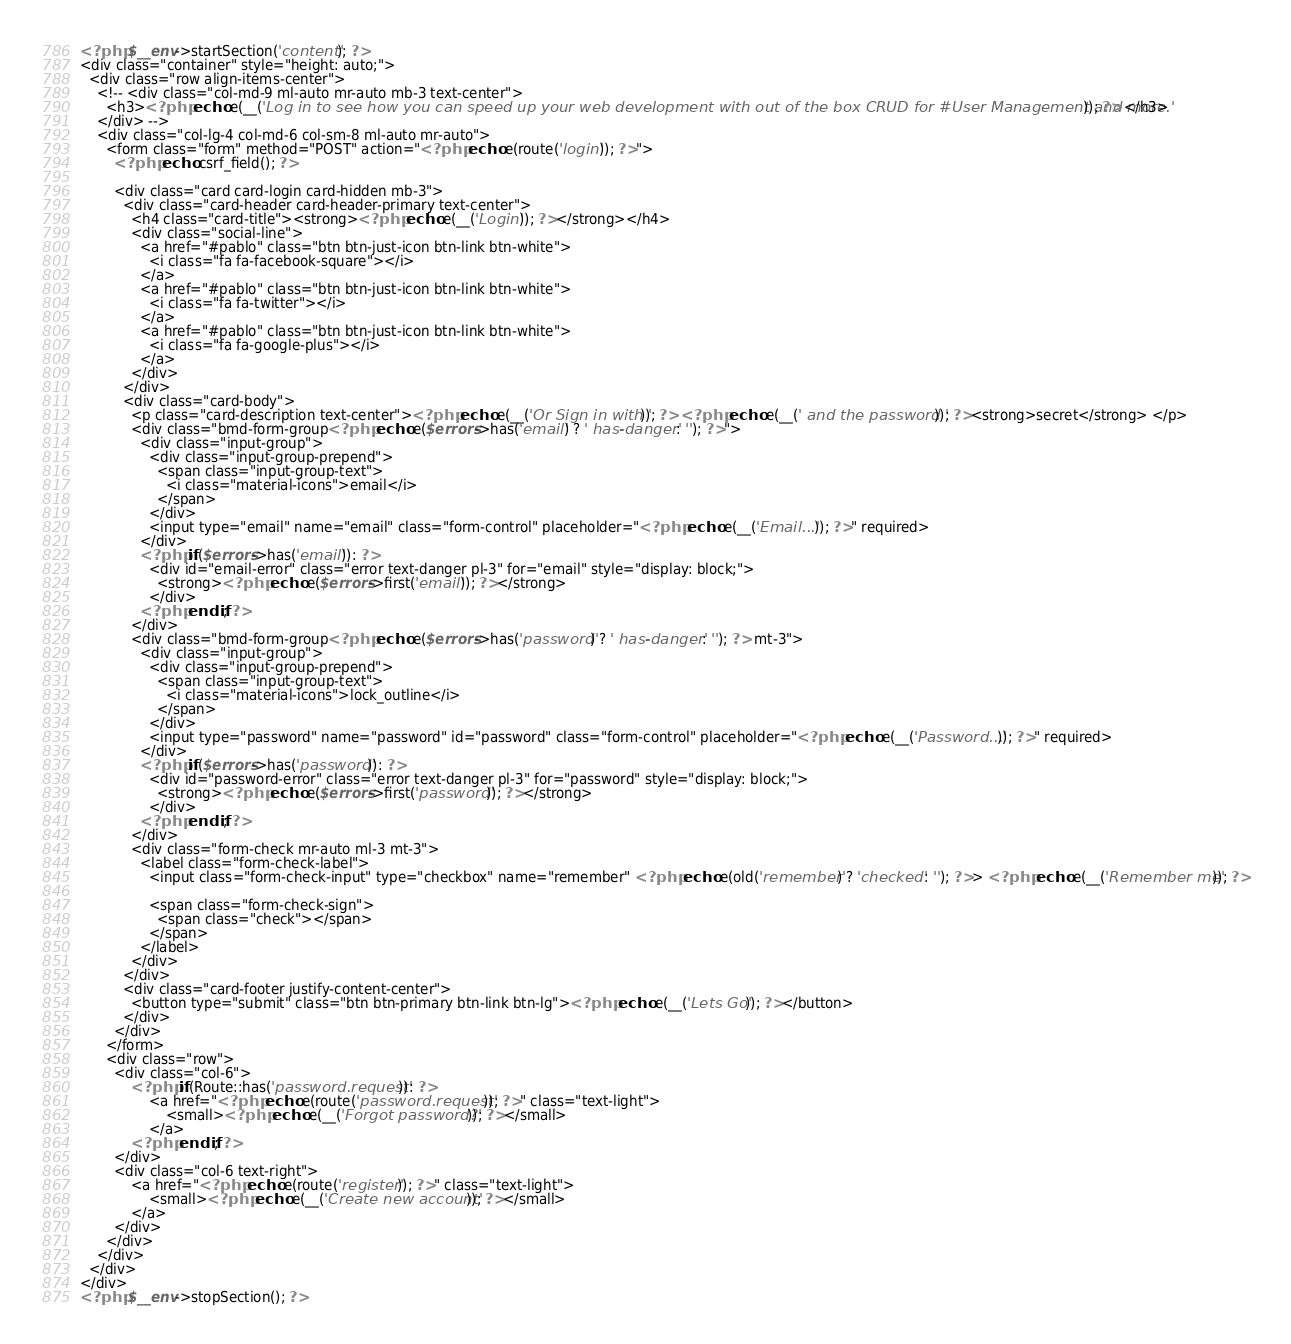Convert code to text. <code><loc_0><loc_0><loc_500><loc_500><_PHP_>

<?php $__env->startSection('content'); ?>
<div class="container" style="height: auto;">
  <div class="row align-items-center">
    <!-- <div class="col-md-9 ml-auto mr-auto mb-3 text-center">
      <h3><?php echo e(__('Log in to see how you can speed up your web development with out of the box CRUD for #User Management and more.')); ?> </h3>
    </div> -->
    <div class="col-lg-4 col-md-6 col-sm-8 ml-auto mr-auto">
      <form class="form" method="POST" action="<?php echo e(route('login')); ?>">
        <?php echo csrf_field(); ?>

        <div class="card card-login card-hidden mb-3">
          <div class="card-header card-header-primary text-center">
            <h4 class="card-title"><strong><?php echo e(__('Login')); ?></strong></h4>
            <div class="social-line">
              <a href="#pablo" class="btn btn-just-icon btn-link btn-white">
                <i class="fa fa-facebook-square"></i>
              </a>
              <a href="#pablo" class="btn btn-just-icon btn-link btn-white">
                <i class="fa fa-twitter"></i>
              </a>
              <a href="#pablo" class="btn btn-just-icon btn-link btn-white">
                <i class="fa fa-google-plus"></i>
              </a>
            </div>
          </div>
          <div class="card-body">
            <p class="card-description text-center"><?php echo e(__('Or Sign in with ')); ?> <?php echo e(__(' and the password ')); ?><strong>secret</strong> </p>
            <div class="bmd-form-group<?php echo e($errors->has('email') ? ' has-danger' : ''); ?>">
              <div class="input-group">
                <div class="input-group-prepend">
                  <span class="input-group-text">
                    <i class="material-icons">email</i>
                  </span>
                </div>
                <input type="email" name="email" class="form-control" placeholder="<?php echo e(__('Email...')); ?>" required>
              </div>
              <?php if($errors->has('email')): ?>
                <div id="email-error" class="error text-danger pl-3" for="email" style="display: block;">
                  <strong><?php echo e($errors->first('email')); ?></strong>
                </div>
              <?php endif; ?>
            </div>
            <div class="bmd-form-group<?php echo e($errors->has('password') ? ' has-danger' : ''); ?> mt-3">
              <div class="input-group">
                <div class="input-group-prepend">
                  <span class="input-group-text">
                    <i class="material-icons">lock_outline</i>
                  </span>
                </div>
                <input type="password" name="password" id="password" class="form-control" placeholder="<?php echo e(__('Password...')); ?>" required>
              </div>
              <?php if($errors->has('password')): ?>
                <div id="password-error" class="error text-danger pl-3" for="password" style="display: block;">
                  <strong><?php echo e($errors->first('password')); ?></strong>
                </div>
              <?php endif; ?>
            </div>
            <div class="form-check mr-auto ml-3 mt-3">
              <label class="form-check-label">
                <input class="form-check-input" type="checkbox" name="remember" <?php echo e(old('remember') ? 'checked' : ''); ?>> <?php echo e(__('Remember me')); ?>

                <span class="form-check-sign">
                  <span class="check"></span>
                </span>
              </label>
            </div>
          </div>
          <div class="card-footer justify-content-center">
            <button type="submit" class="btn btn-primary btn-link btn-lg"><?php echo e(__('Lets Go')); ?></button>
          </div>
        </div>
      </form>
      <div class="row">
        <div class="col-6">
            <?php if(Route::has('password.request')): ?>
                <a href="<?php echo e(route('password.request')); ?>" class="text-light">
                    <small><?php echo e(__('Forgot password?')); ?></small>
                </a>
            <?php endif; ?>
        </div>
        <div class="col-6 text-right">
            <a href="<?php echo e(route('register')); ?>" class="text-light">
                <small><?php echo e(__('Create new account')); ?></small>
            </a>
        </div>
      </div>
    </div>
  </div>
</div>
<?php $__env->stopSection(); ?>
</code> 